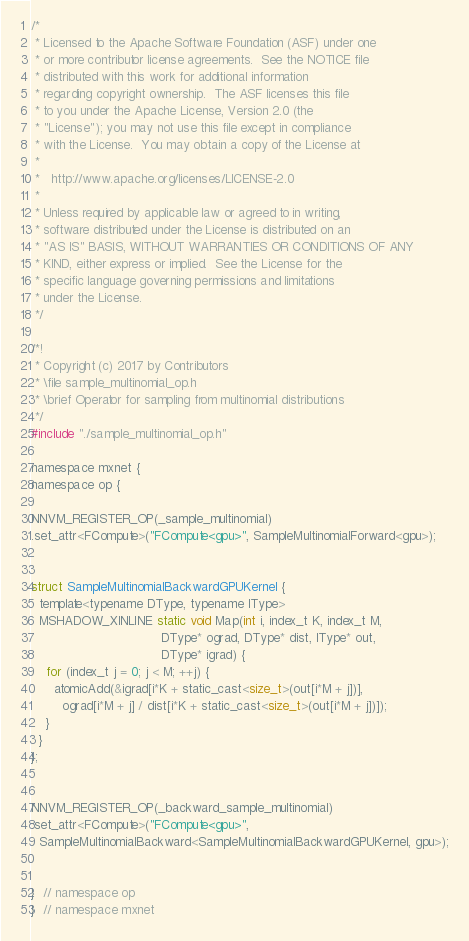Convert code to text. <code><loc_0><loc_0><loc_500><loc_500><_Cuda_>/*
 * Licensed to the Apache Software Foundation (ASF) under one
 * or more contributor license agreements.  See the NOTICE file
 * distributed with this work for additional information
 * regarding copyright ownership.  The ASF licenses this file
 * to you under the Apache License, Version 2.0 (the
 * "License"); you may not use this file except in compliance
 * with the License.  You may obtain a copy of the License at
 *
 *   http://www.apache.org/licenses/LICENSE-2.0
 *
 * Unless required by applicable law or agreed to in writing,
 * software distributed under the License is distributed on an
 * "AS IS" BASIS, WITHOUT WARRANTIES OR CONDITIONS OF ANY
 * KIND, either express or implied.  See the License for the
 * specific language governing permissions and limitations
 * under the License.
 */

/*!
 * Copyright (c) 2017 by Contributors
 * \file sample_multinomial_op.h
 * \brief Operator for sampling from multinomial distributions
 */
#include "./sample_multinomial_op.h"

namespace mxnet {
namespace op {

NNVM_REGISTER_OP(_sample_multinomial)
.set_attr<FCompute>("FCompute<gpu>", SampleMultinomialForward<gpu>);


struct SampleMultinomialBackwardGPUKernel {
  template<typename DType, typename IType>
  MSHADOW_XINLINE static void Map(int i, index_t K, index_t M,
                                  DType* ograd, DType* dist, IType* out,
                                  DType* igrad) {
    for (index_t j = 0; j < M; ++j) {
      atomicAdd(&igrad[i*K + static_cast<size_t>(out[i*M + j])],
        ograd[i*M + j] / dist[i*K + static_cast<size_t>(out[i*M + j])]);
    }
  }
};


NNVM_REGISTER_OP(_backward_sample_multinomial)
.set_attr<FCompute>("FCompute<gpu>",
  SampleMultinomialBackward<SampleMultinomialBackwardGPUKernel, gpu>);


}  // namespace op
}  // namespace mxnet
</code> 